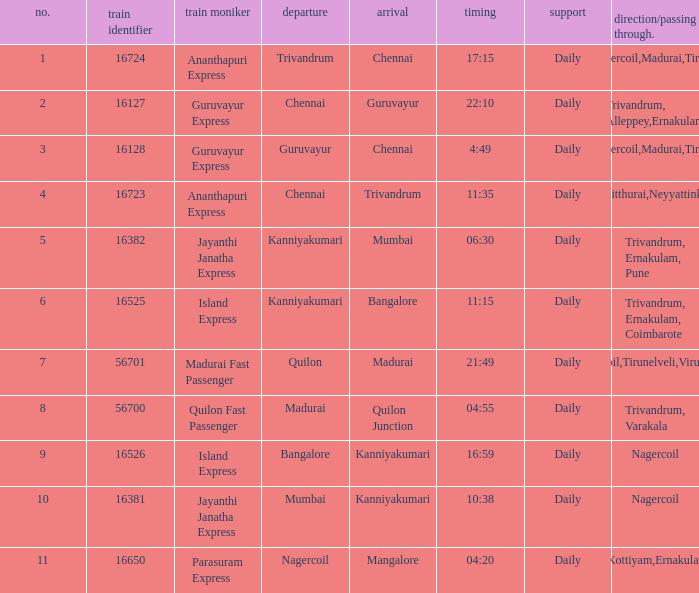What is the train number when the time is 10:38? 16381.0. 